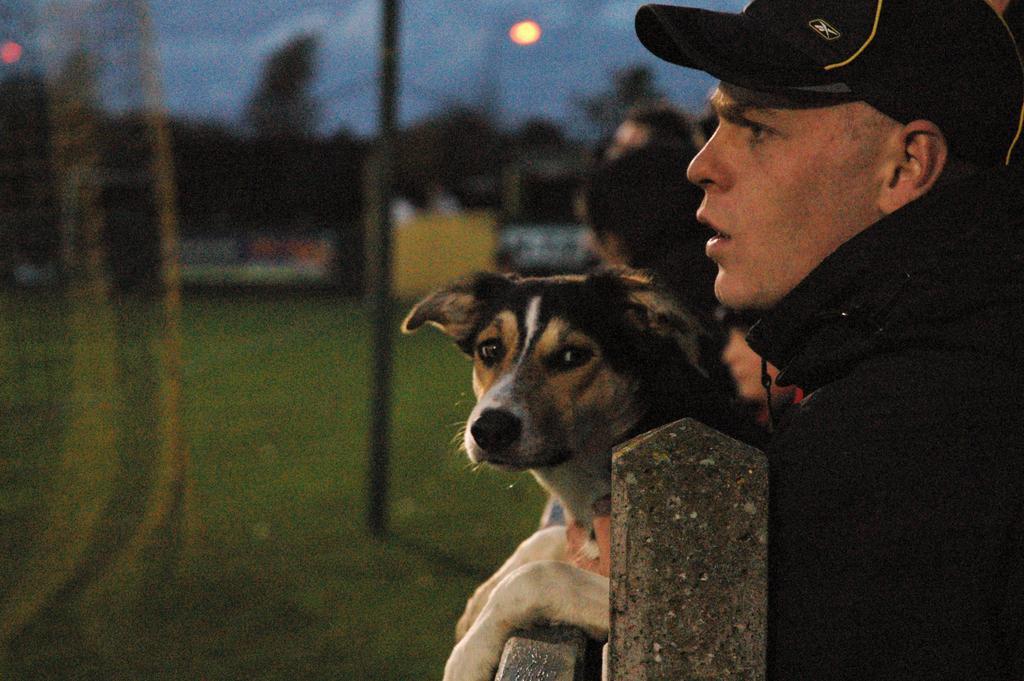Can you describe this image briefly? In this image I can see a man and a dog. I can also see he is wearing a cap. 